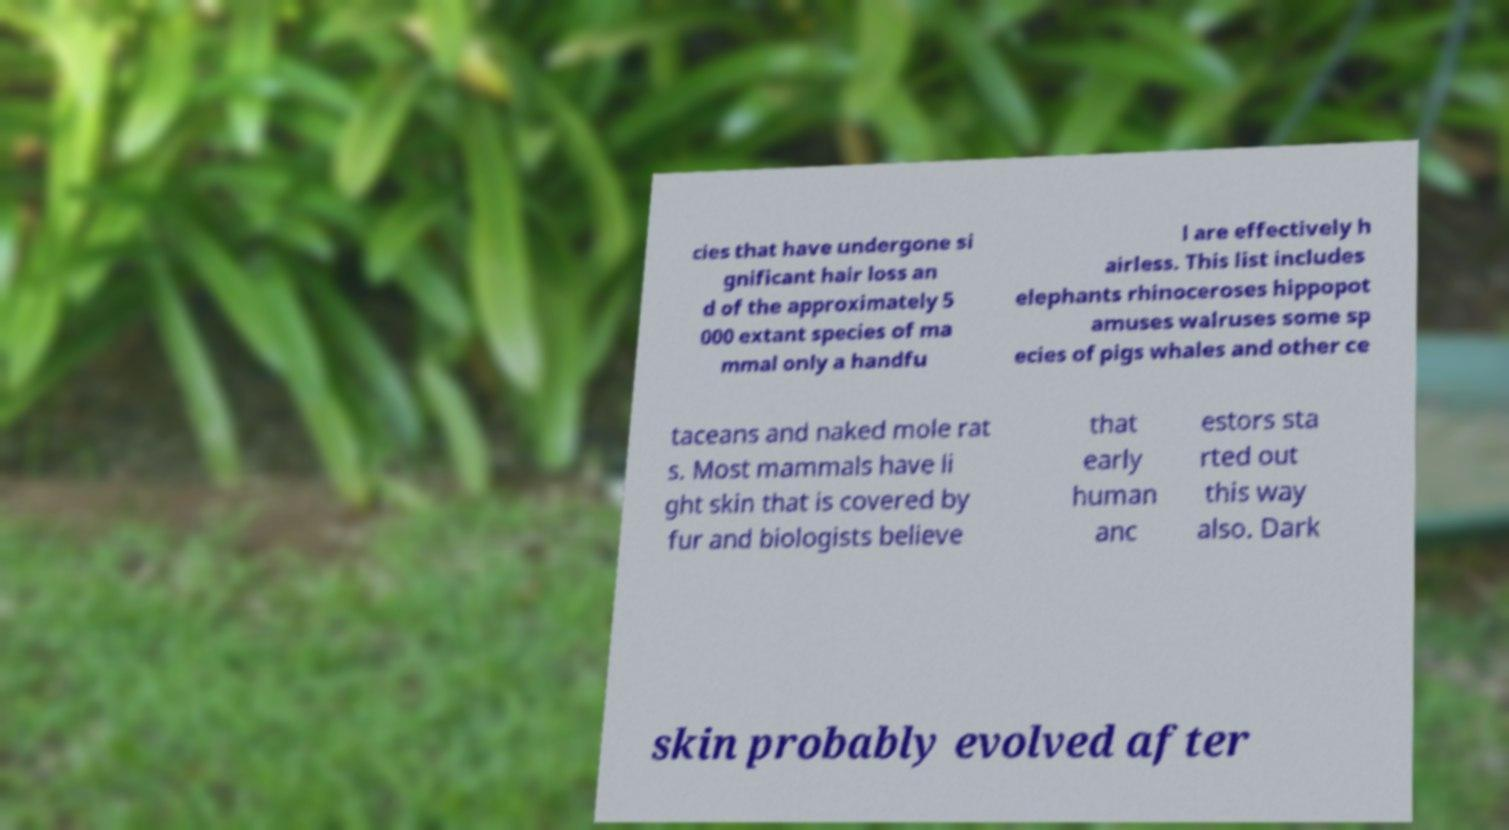Please identify and transcribe the text found in this image. cies that have undergone si gnificant hair loss an d of the approximately 5 000 extant species of ma mmal only a handfu l are effectively h airless. This list includes elephants rhinoceroses hippopot amuses walruses some sp ecies of pigs whales and other ce taceans and naked mole rat s. Most mammals have li ght skin that is covered by fur and biologists believe that early human anc estors sta rted out this way also. Dark skin probably evolved after 